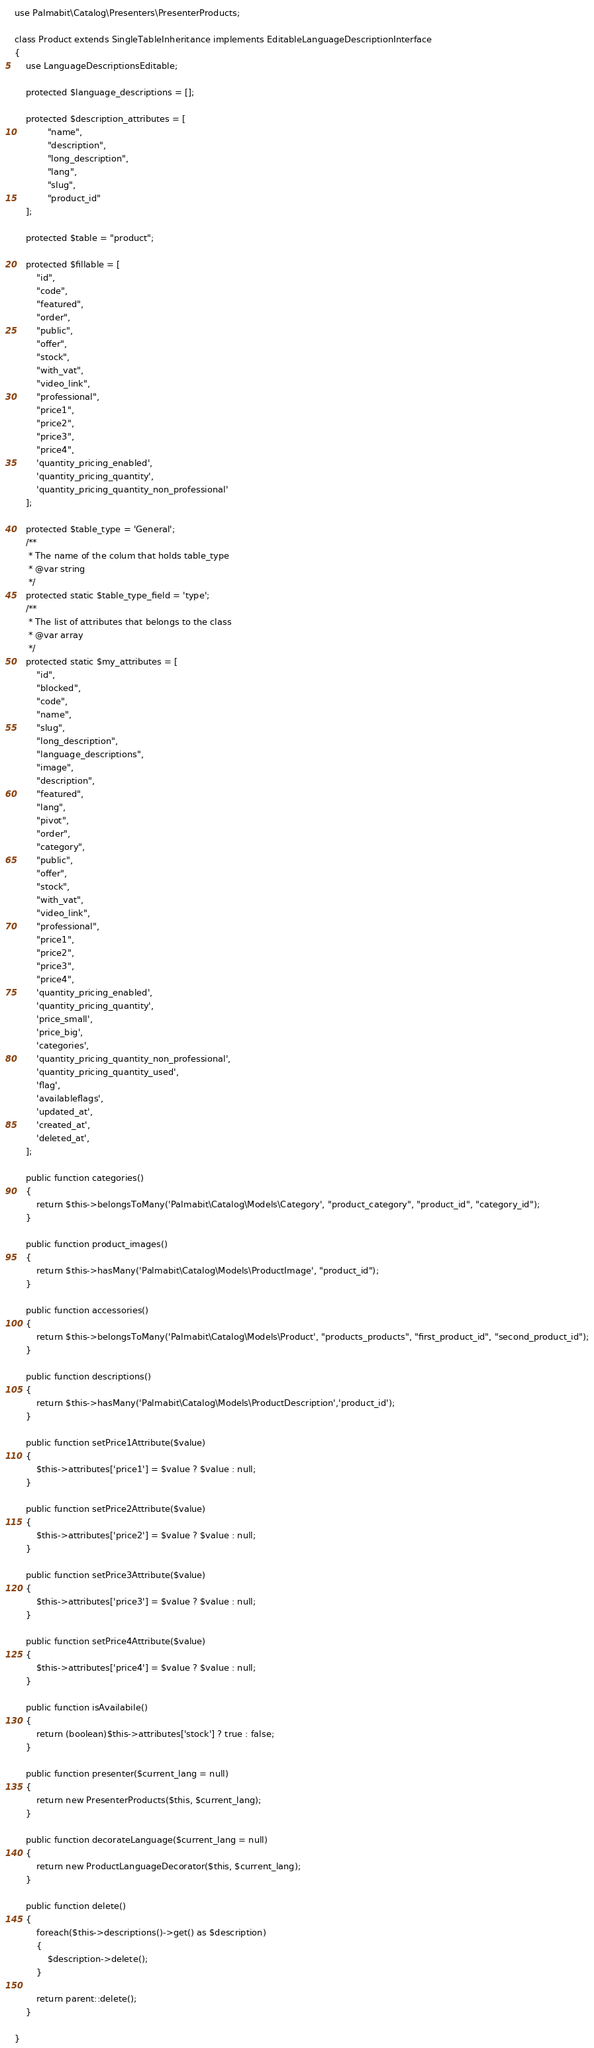<code> <loc_0><loc_0><loc_500><loc_500><_PHP_>use Palmabit\Catalog\Presenters\PresenterProducts;

class Product extends SingleTableInheritance implements EditableLanguageDescriptionInterface
{
    use LanguageDescriptionsEditable;

    protected $language_descriptions = [];

    protected $description_attributes = [
            "name",
            "description",
            "long_description",
            "lang",
            "slug",
            "product_id"
    ];

    protected $table = "product";

    protected $fillable = [
        "id",
        "code",
        "featured",
        "order",
        "public",
        "offer",
        "stock",
        "with_vat",
        "video_link",
        "professional",
        "price1",
        "price2",
        "price3",
        "price4",
        'quantity_pricing_enabled',
        'quantity_pricing_quantity',
        'quantity_pricing_quantity_non_professional'
    ];

    protected $table_type = 'General';
    /**
     * The name of the colum that holds table_type
     * @var string
     */
    protected static $table_type_field = 'type';
    /**
     * The list of attributes that belongs to the class
     * @var array
     */
    protected static $my_attributes = [
        "id",
        "blocked",
        "code",
        "name",
        "slug",
        "long_description",
        "language_descriptions",
        "image",
        "description",
        "featured",
        "lang",
        "pivot",
        "order",
        "category",
        "public",
        "offer",
        "stock",
        "with_vat",
        "video_link",
        "professional",
        "price1",
        "price2",
        "price3",
        "price4",
        'quantity_pricing_enabled',
        'quantity_pricing_quantity',
        'price_small',
        'price_big',
        'categories',
        'quantity_pricing_quantity_non_professional',
        'quantity_pricing_quantity_used',
        'flag',
        'availableflags',
        'updated_at',
        'created_at',
        'deleted_at',
    ];

    public function categories()
    {
        return $this->belongsToMany('Palmabit\Catalog\Models\Category', "product_category", "product_id", "category_id");
    }

    public function product_images()
    {
        return $this->hasMany('Palmabit\Catalog\Models\ProductImage', "product_id");
    }

    public function accessories()
    {
        return $this->belongsToMany('Palmabit\Catalog\Models\Product', "products_products", "first_product_id", "second_product_id");
    }

    public function descriptions()
    {
        return $this->hasMany('Palmabit\Catalog\Models\ProductDescription','product_id');
    }
    
    public function setPrice1Attribute($value)
    {
        $this->attributes['price1'] = $value ? $value : null;
    }

    public function setPrice2Attribute($value)
    {
        $this->attributes['price2'] = $value ? $value : null;
    }

    public function setPrice3Attribute($value)
    {
        $this->attributes['price3'] = $value ? $value : null;
    }

    public function setPrice4Attribute($value)
    {
        $this->attributes['price4'] = $value ? $value : null;
    }

    public function isAvailabile()
    {
        return (boolean)$this->attributes['stock'] ? true : false;
    }

    public function presenter($current_lang = null)
    {
        return new PresenterProducts($this, $current_lang);
    }

    public function decorateLanguage($current_lang = null)
    {
        return new ProductLanguageDecorator($this, $current_lang);
    }

    public function delete()
    {
        foreach($this->descriptions()->get() as $description)
        {
            $description->delete();
        }

        return parent::delete();
    }

}</code> 